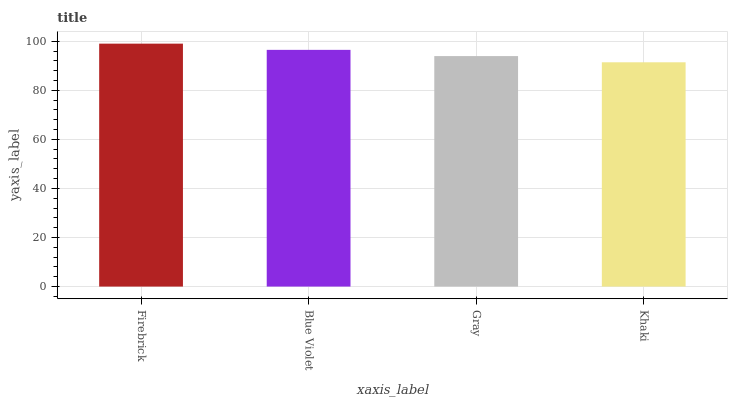Is Khaki the minimum?
Answer yes or no. Yes. Is Firebrick the maximum?
Answer yes or no. Yes. Is Blue Violet the minimum?
Answer yes or no. No. Is Blue Violet the maximum?
Answer yes or no. No. Is Firebrick greater than Blue Violet?
Answer yes or no. Yes. Is Blue Violet less than Firebrick?
Answer yes or no. Yes. Is Blue Violet greater than Firebrick?
Answer yes or no. No. Is Firebrick less than Blue Violet?
Answer yes or no. No. Is Blue Violet the high median?
Answer yes or no. Yes. Is Gray the low median?
Answer yes or no. Yes. Is Gray the high median?
Answer yes or no. No. Is Firebrick the low median?
Answer yes or no. No. 